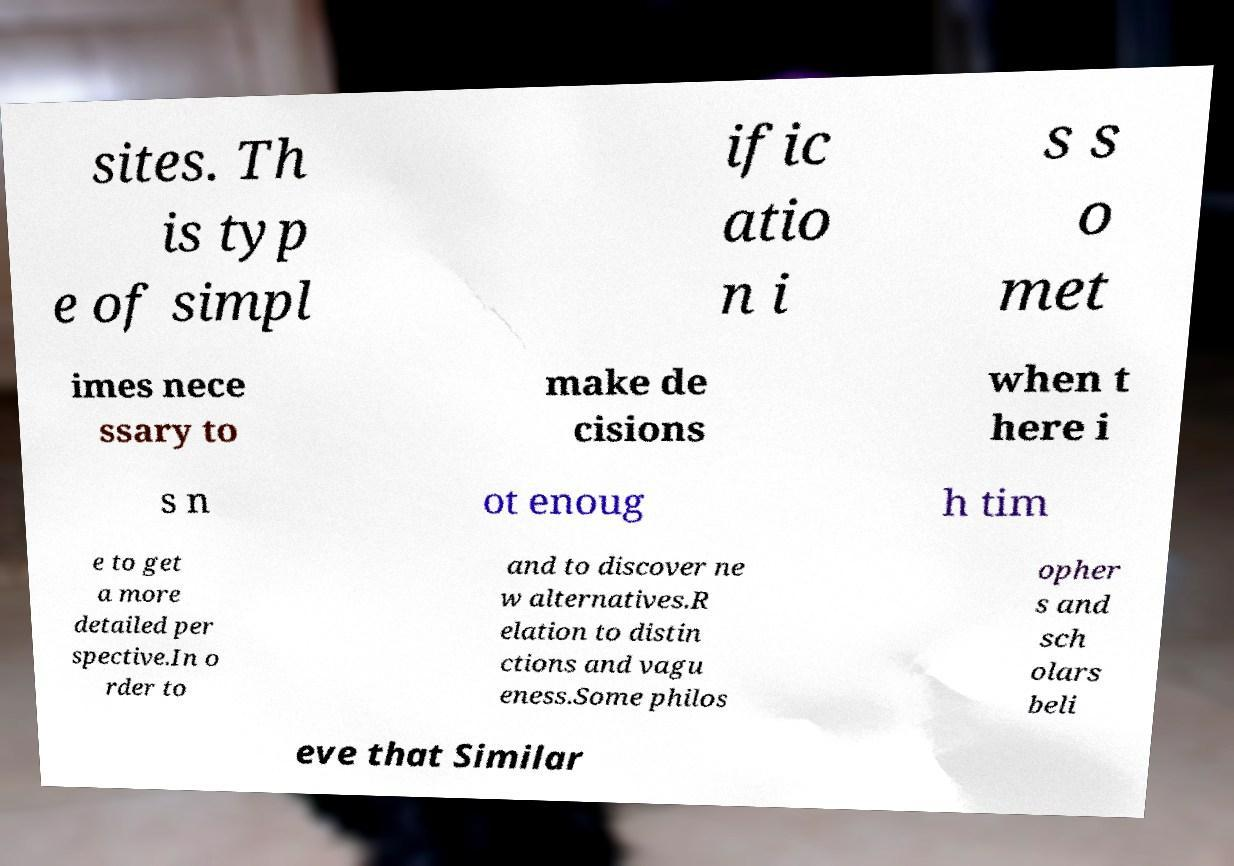Could you assist in decoding the text presented in this image and type it out clearly? sites. Th is typ e of simpl ific atio n i s s o met imes nece ssary to make de cisions when t here i s n ot enoug h tim e to get a more detailed per spective.In o rder to and to discover ne w alternatives.R elation to distin ctions and vagu eness.Some philos opher s and sch olars beli eve that Similar 